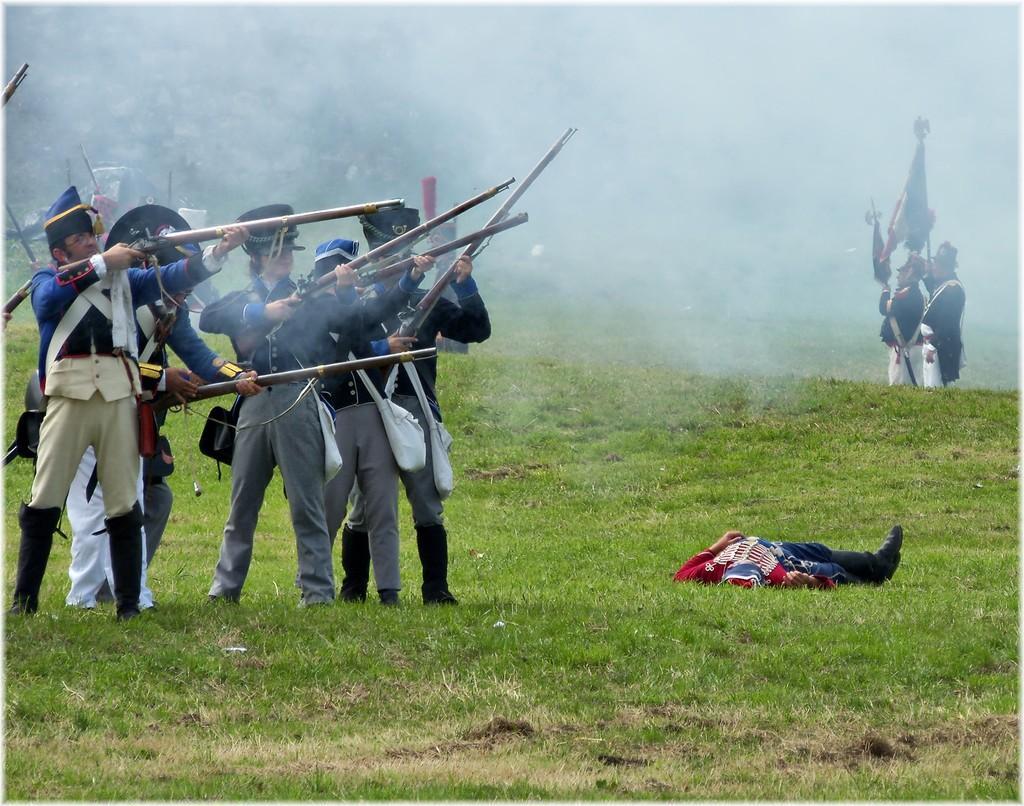Describe this image in one or two sentences. In this image there are group of persons standing. In the center there is a man laying on the ground. There is grass on the ground. In the background there is fog. In the front on the left side there are persons standing and holding guns. 